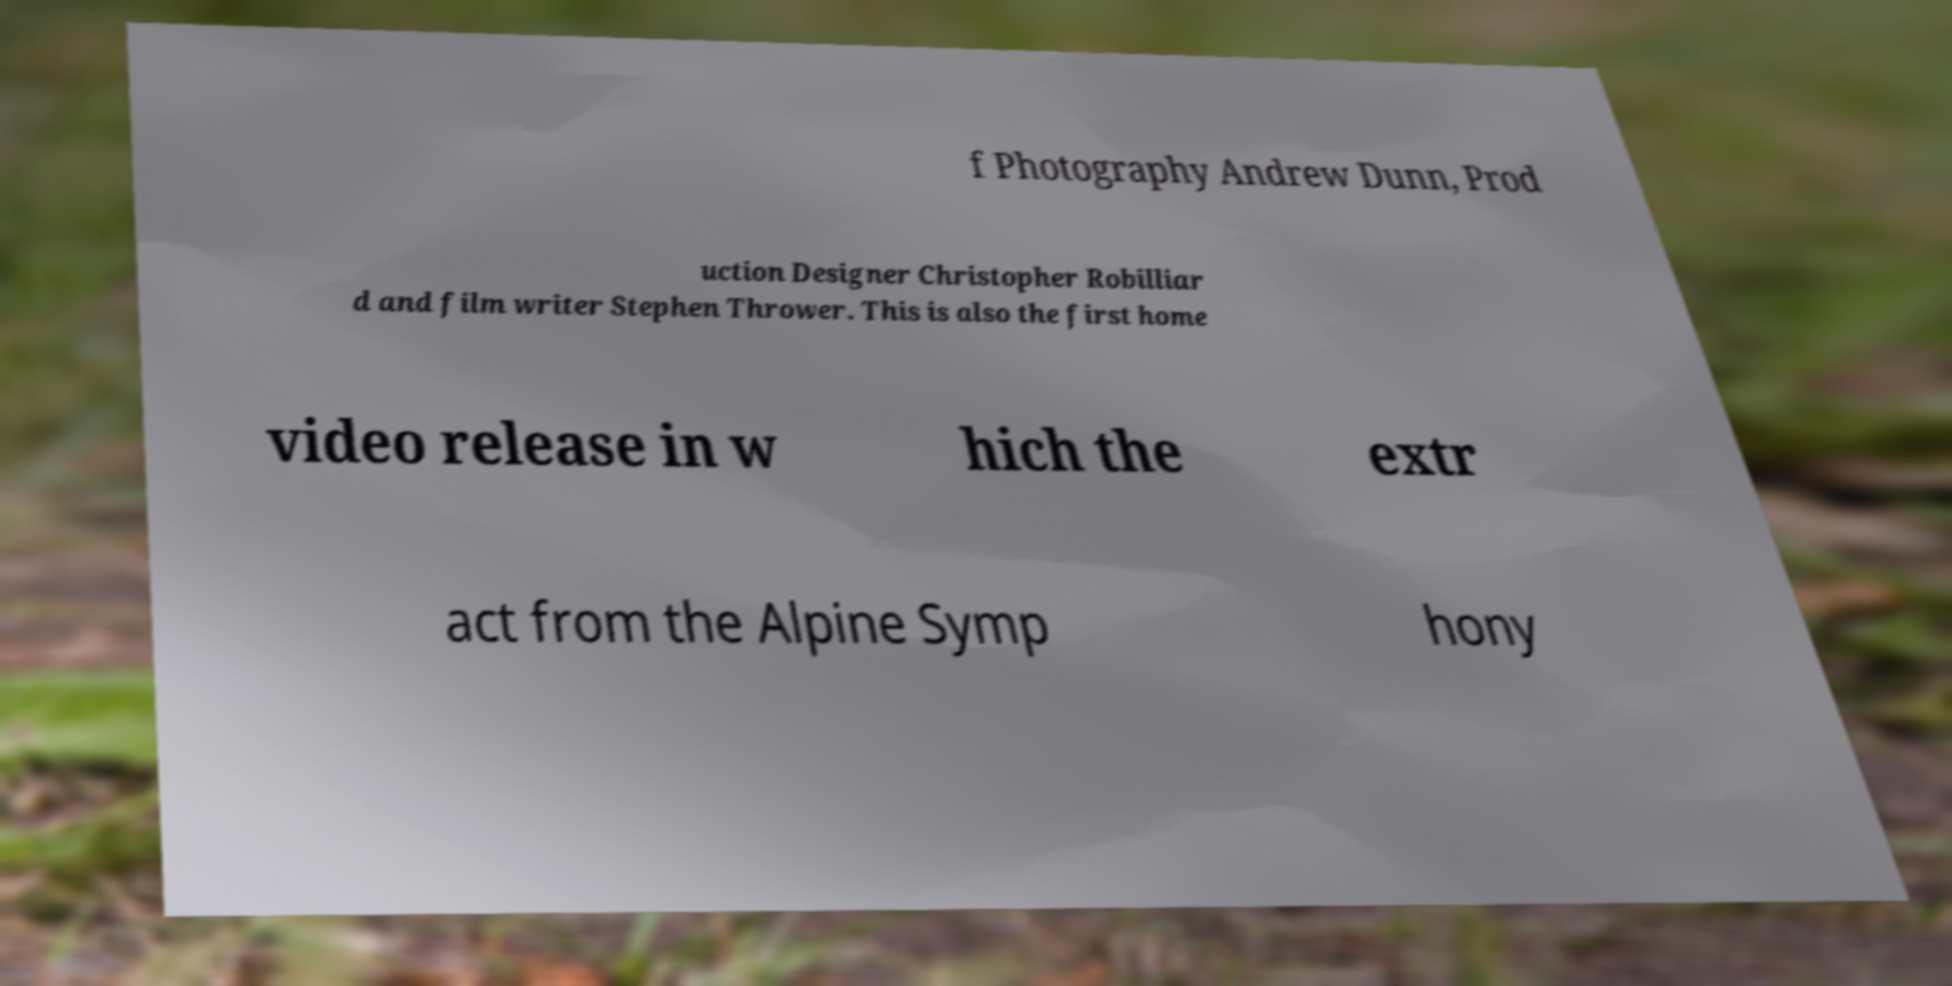What messages or text are displayed in this image? I need them in a readable, typed format. f Photography Andrew Dunn, Prod uction Designer Christopher Robilliar d and film writer Stephen Thrower. This is also the first home video release in w hich the extr act from the Alpine Symp hony 